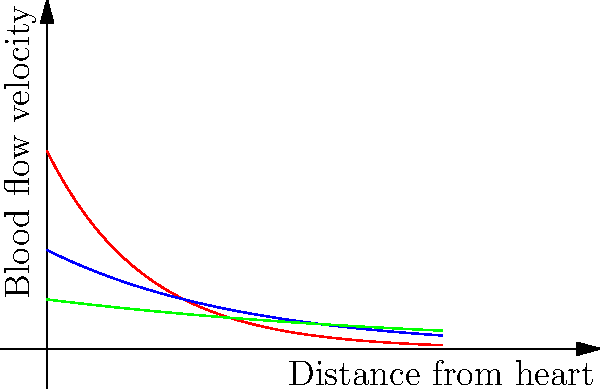As a science journalist familiar with the work of Nobel laureates in genetics, you're writing an article on the biomechanics of blood flow. Based on the graph showing blood flow velocity in different types of vessels, which type of blood vessel exhibits the highest initial velocity but also the steepest decline in velocity as distance from the heart increases? To answer this question, we need to analyze the graph and understand the characteristics of each curve:

1. The red curve represents arteries, the blue curve represents capillaries, and the green curve represents veins.

2. We need to look at two factors:
   a) The initial velocity (y-intercept)
   b) The rate of decline (steepness of the curve)

3. Comparing the initial velocities:
   - Arteries (red): Highest initial velocity
   - Capillaries (blue): Medium initial velocity
   - Veins (green): Lowest initial velocity

4. Analyzing the rate of decline:
   - Arteries: Steepest decline
   - Capillaries: Moderate decline
   - Veins: Gradual decline

5. The curve that meets both criteria (highest initial velocity and steepest decline) is the red curve, representing arteries.

This behavior can be explained by the fact that blood leaves the heart at high pressure and velocity through the arteries. As it moves further from the heart and into smaller vessels, it loses velocity due to factors such as friction and increased total cross-sectional area of the circulatory system.
Answer: Arteries 